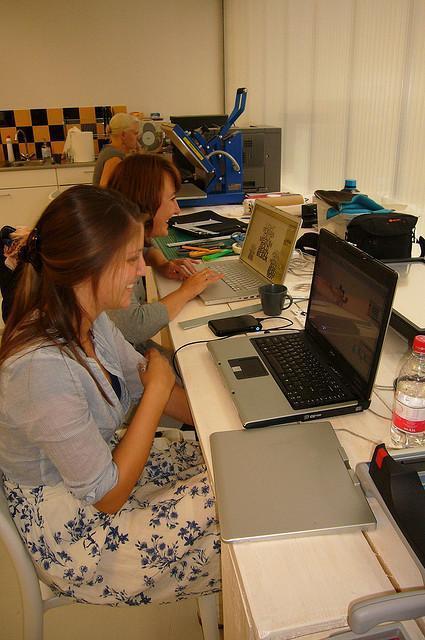How many laptops are there?
Give a very brief answer. 3. How many people can be seen?
Give a very brief answer. 2. 